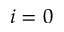Convert formula to latex. <formula><loc_0><loc_0><loc_500><loc_500>i = 0</formula> 